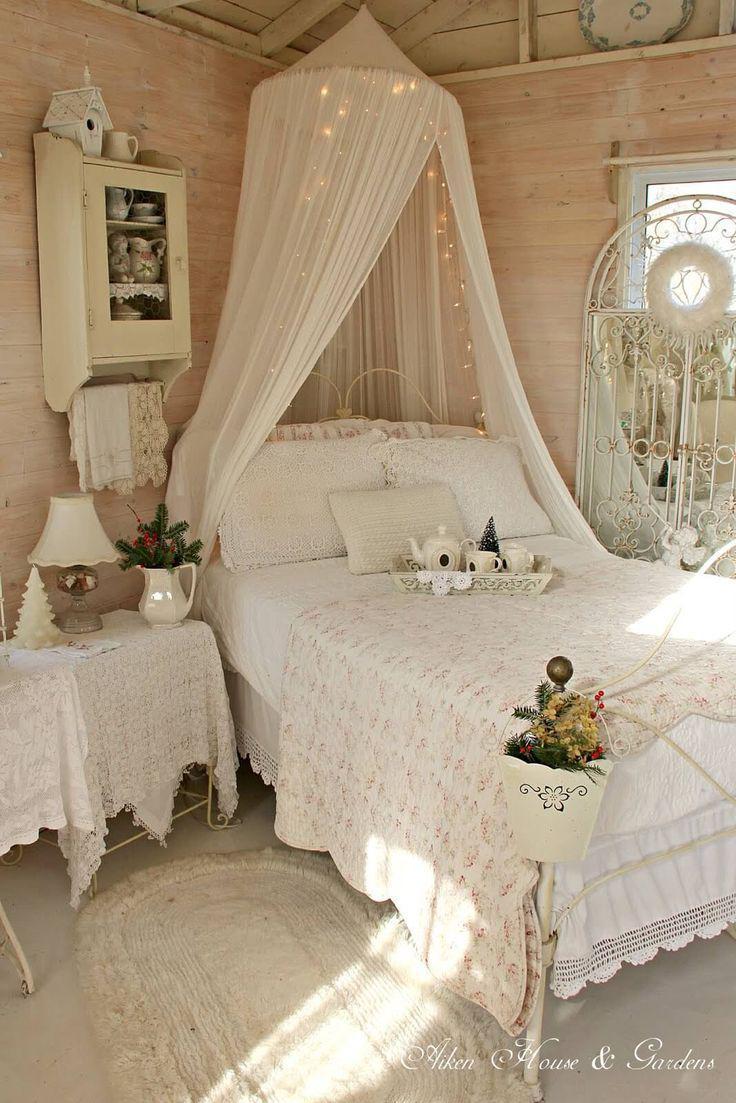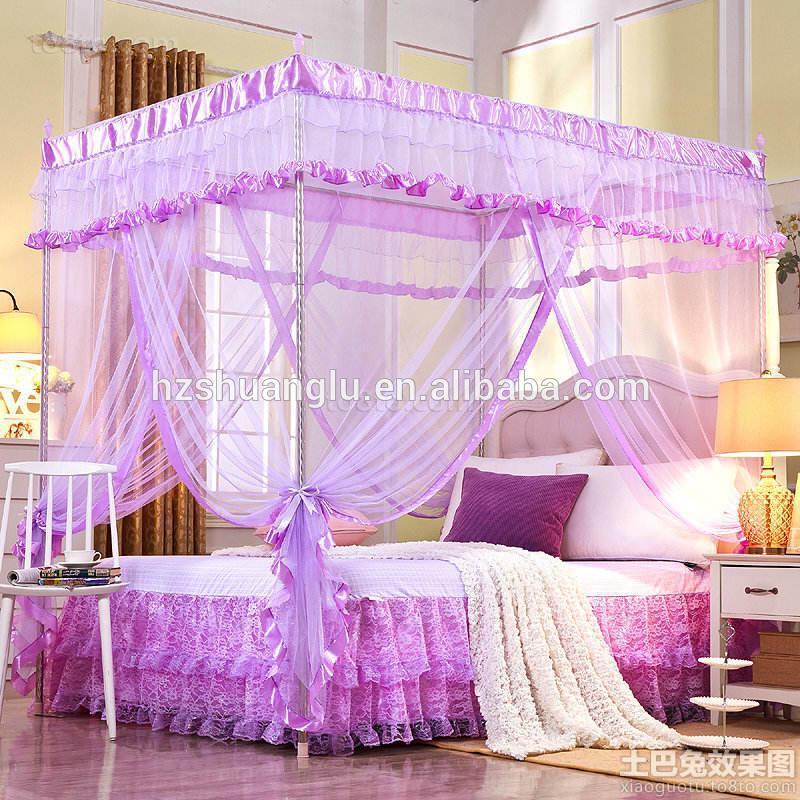The first image is the image on the left, the second image is the image on the right. Evaluate the accuracy of this statement regarding the images: "The bedposts in one image have a draping that is lavender.". Is it true? Answer yes or no. Yes. The first image is the image on the left, the second image is the image on the right. For the images displayed, is the sentence "An image shows a four-posted bed decorated with a curtain-tied lavender canopy." factually correct? Answer yes or no. Yes. 